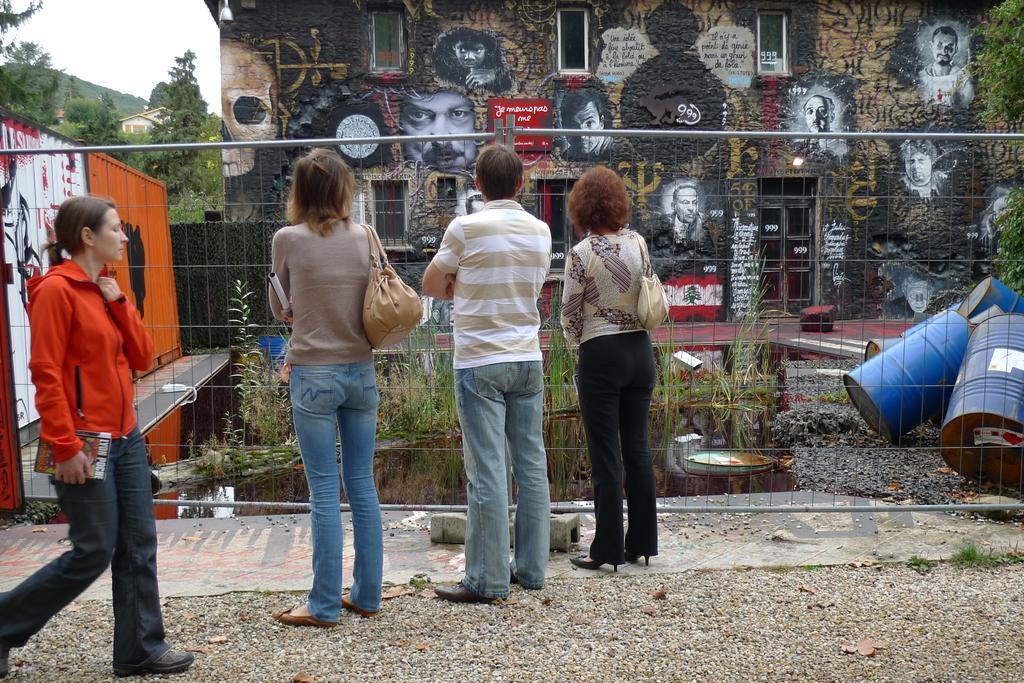Describe this image in one or two sentences. In this image, we can see some people standing, there is a fence. We can see some barrels on the right side. There is a wall and we can see some paintings on the wall. We can see some trees and the sky. 